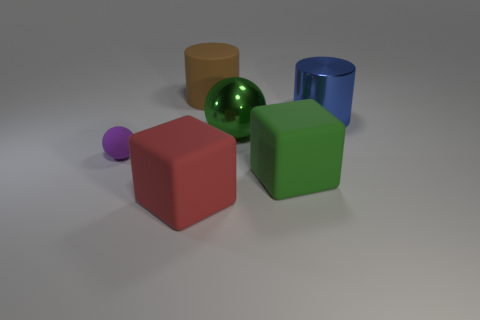Are there the same number of purple matte balls in front of the purple sphere and red matte objects right of the big green metallic sphere?
Keep it short and to the point. Yes. There is a big block that is behind the rubber cube that is to the left of the big green object behind the purple object; what is its color?
Provide a short and direct response. Green. Are there any other things that have the same color as the rubber cylinder?
Your response must be concise. No. What is the shape of the rubber thing that is the same color as the metallic sphere?
Your answer should be compact. Cube. What size is the sphere that is right of the brown object?
Your answer should be compact. Large. There is a green matte thing that is the same size as the rubber cylinder; what is its shape?
Offer a terse response. Cube. Do the big cylinder behind the large blue cylinder and the large green object that is on the left side of the large green rubber cube have the same material?
Your response must be concise. No. The green thing behind the sphere on the left side of the big red matte thing is made of what material?
Offer a terse response. Metal. How big is the matte object to the left of the object in front of the large matte block that is to the right of the big red matte object?
Provide a succinct answer. Small. Do the brown cylinder and the green shiny thing have the same size?
Provide a succinct answer. Yes. 